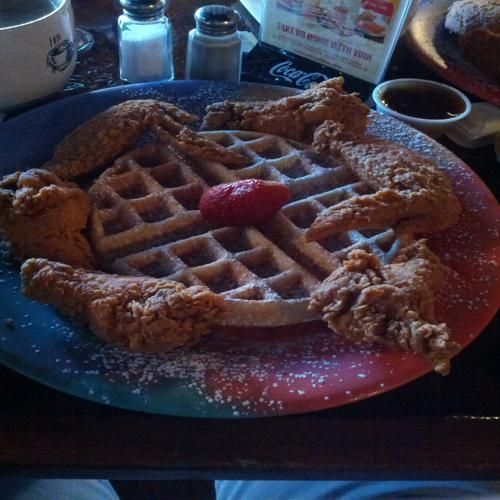Are there any focus issues in the image? Upon close examination, the image appears sharp and in focus, with details such as the texture of the chicken breading and the indentations of the waffle being quite clear. 